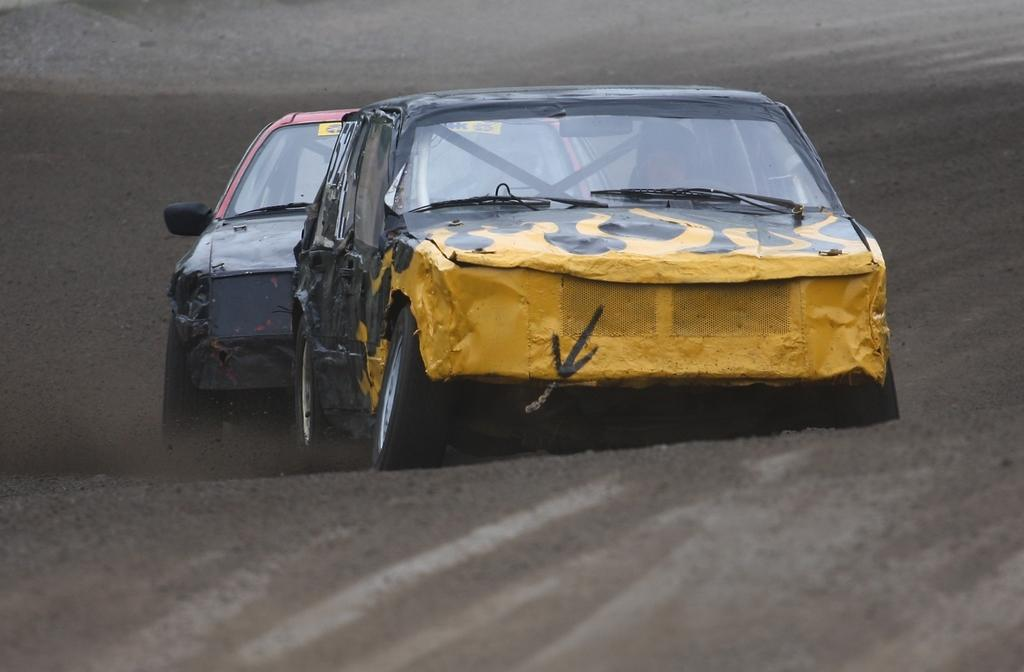How many cars are visible in the image? There are two cars in the image. Where are the cars located? The cars are on the road. What colors can be seen on the front car? The front car is blue and yellow. What type of animal is sitting on top of the blue and yellow car in the image? There is no animal sitting on top of the blue and yellow car in the image. What liquid can be seen dripping from the cars in the image? There is no liquid dripping from the cars in the image. 